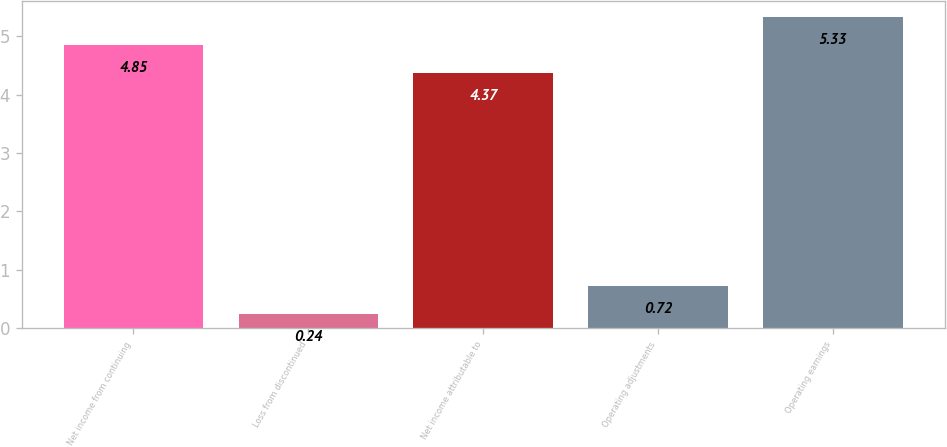Convert chart to OTSL. <chart><loc_0><loc_0><loc_500><loc_500><bar_chart><fcel>Net income from continuing<fcel>Loss from discontinued<fcel>Net income attributable to<fcel>Operating adjustments<fcel>Operating earnings<nl><fcel>4.85<fcel>0.24<fcel>4.37<fcel>0.72<fcel>5.33<nl></chart> 